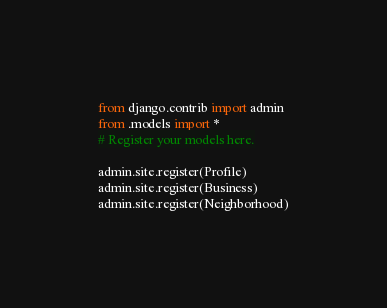Convert code to text. <code><loc_0><loc_0><loc_500><loc_500><_Python_>from django.contrib import admin
from .models import *
# Register your models here.

admin.site.register(Profile)
admin.site.register(Business)
admin.site.register(Neighborhood)</code> 